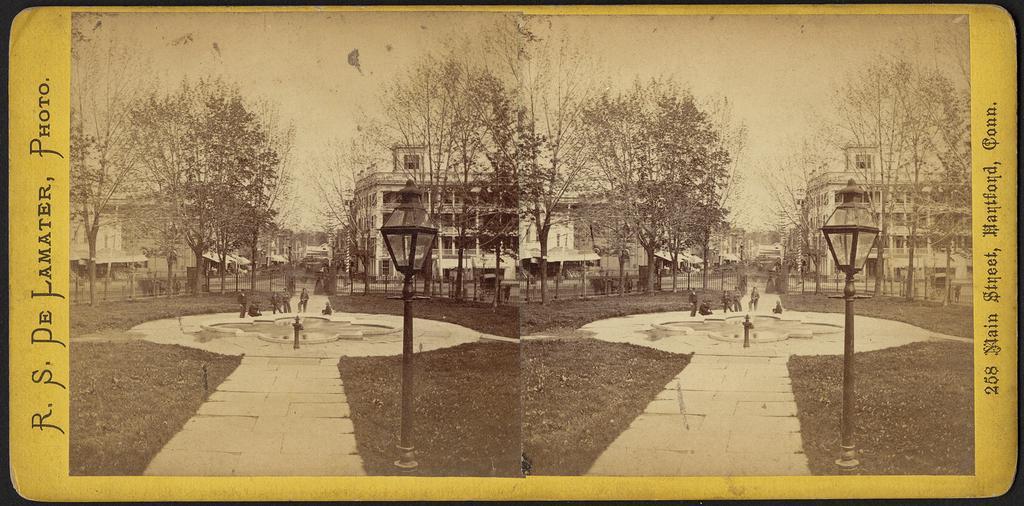How would you summarize this image in a sentence or two? This is a black and white picture. This is an edited image. This picture has two images. One image is same as the other. At the bottom, we see the grass and a light pole. In the middle of the picture, we see the fountain and people standing beside that. There are trees and buildings in the background. At the top, we see the sky. On the left side, we see some text written. This picture is a photo frame. 